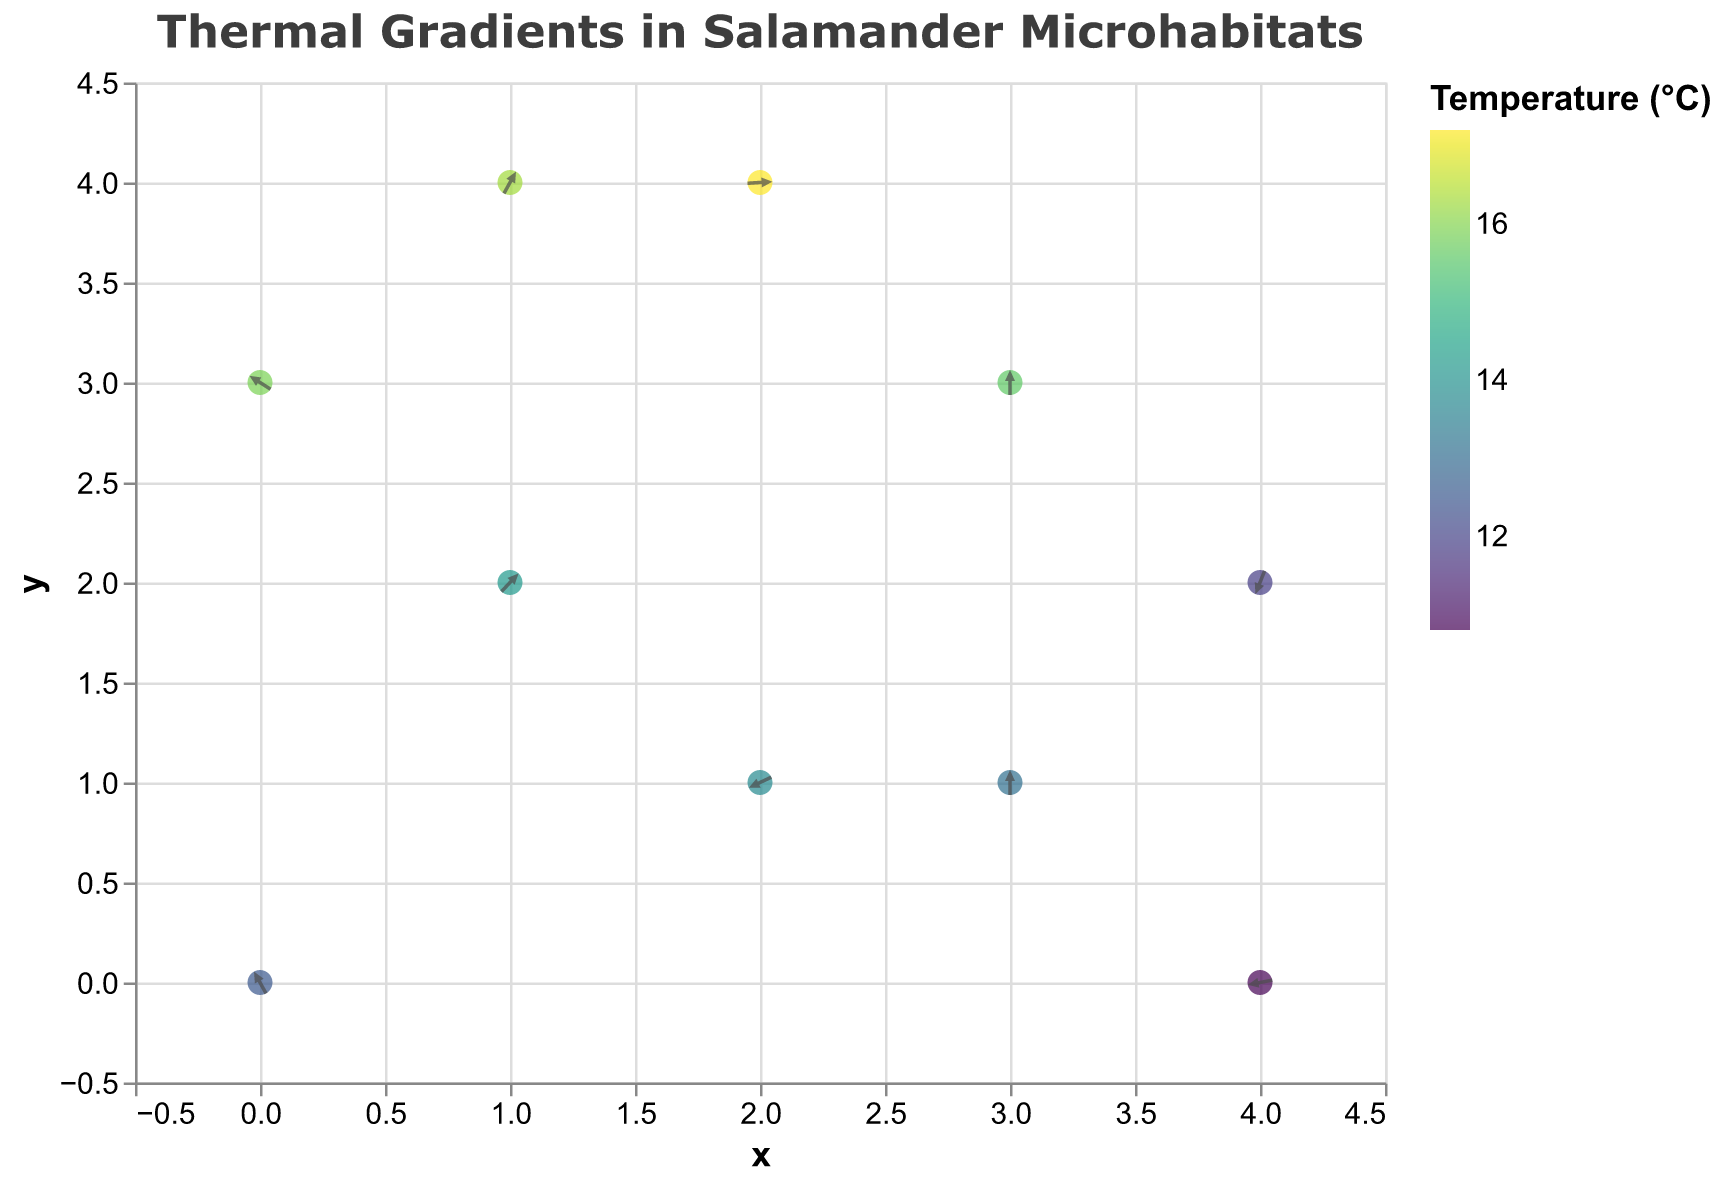What is the title of the figure? The title of a figure is usually displayed at the top. Here, it is "Thermal Gradients in Salamander Microhabitats".
Answer: Thermal Gradients in Salamander Microhabitats How many different species of salamanders are represented in the plot? Each data point has a tooltip showing the species. There are 10 data points, but some species may appear more than once. We need to count the unique species names.
Answer: 8 What is the range of temperatures shown in the plot? The color legend indicates the temperature range. The plot includes values from 10.8°C to 17.2°C.
Answer: 10.8°C to 17.2°C Which species is represented at coordinates (4, 0), and what is its temperature? Using the tooltip for coordinates (4, 0), the species is Ambystoma jeffersonianum, and the temperature is given as 10.8°C.
Answer: Ambystoma jeffersonianum, 10.8°C What are the x and y axis scales in the plot? The axis labels and ticks show numeric ranges. Both axes range from -0.5 to 4.5.
Answer: -0.5 to 4.5 Which species is found in the warmest microhabitat? By comparing the data points' temperatures, the highest temperature is 17.2°C, associated with Notophthalmus viridescens.
Answer: Notophthalmus viridescens How many data points have arrows pointing upwards? An arrow points upward if its v-component is positive. Count the arrows where v > 0. Five arrows satisfy this criterion.
Answer: 5 What is the direction of the gradient vector for Plethodon cinereus at (0, 3)? The gradient vector is represented by the arrow direction, given by u and v values. For (0, 3), Plethodon cinereus has u=1.0 and v=1.4, indicating an upward and rightward direction.
Answer: Up and Right Compare the temperatures of Plethodon cinereus at (0,0) and (0,3). Which one is higher? Inspecting the temperatures at these coordinates: (0,0) has 12.5°C and (0,3) has 15.9°C. The latter is higher.
Answer: (0,3) Which species has the longest vector, and what is its magnitude? To find the longest vector, calculate the magnitude using the formula √(u² + v²) for each species. Gyrinophilus porphyriticus at (3,1) has u=1.4 and v=0.2, yielding the longest vector with a magnitude of √(1.4² + 0.2²) ≈ 1.415.
Answer: Gyrinophilus porphyriticus, 1.415 